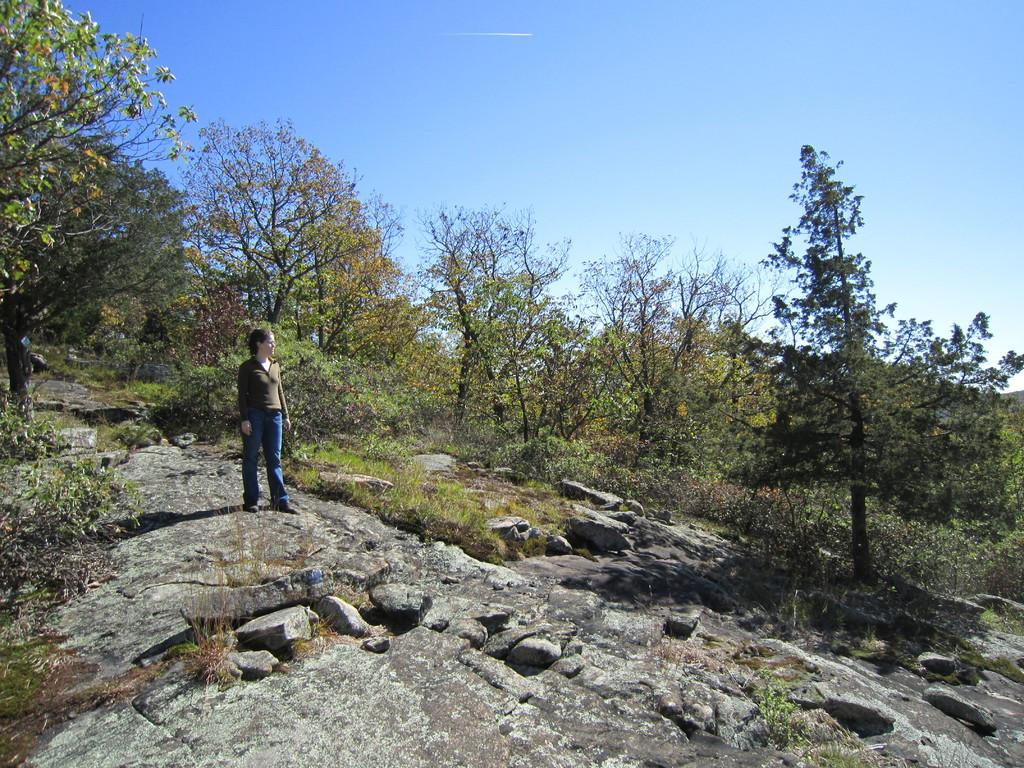What is the main subject of the image? There is a person in the image. What is the person wearing? The person is wearing a grey T-shirt and jeans. Where is the person standing? The person is standing on rocks. What other objects can be seen in the image? There are stones and trees in the image. What is visible in the background of the image? The sky is blue in the background of the image. What shape is the mailbox in the image? There is no mailbox present in the image. What type of building can be seen in the background of the image? There is no building visible in the background of the image; only trees and the blue sky are present. 